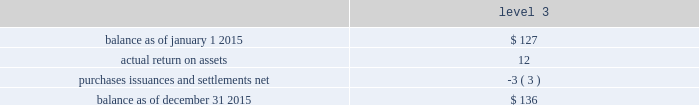The tables present a reconciliation of the beginning and ending balances of the fair value measurements using significant unobservable inputs ( level 3 ) for 2015 and 2014 , respectively: .
Purchases , issuances and settlements , net .
76 balance as of december 31 , 2014 .
$ 127 the company 2019s other postretirement benefit plans are partially funded and the assets are held under various trusts .
The investments and risk mitigation strategies for the plans are tailored specifically for each trust .
In setting new strategic asset mixes , consideration is given to the likelihood that the selected asset allocation will effectively fund the projected plan liabilities and the risk tolerance of the company .
The company periodically updates the long-term , strategic asset allocations and uses various analytics to determine the optimal asset allocation .
Considerations include plan liability characteristics , liquidity characteristics , funding requirements , expected rates of return and the distribution of returns .
In june 2012 , the company implemented a de-risking strategy for the medical bargaining trust within the plan to minimize volatility .
As part of the de-risking strategy , the company revised the asset allocations to increase the matching characteristics of assets relative to liabilities .
The initial de-risking asset allocation for the plan was 60% ( 60 % ) return-generating assets and 40% ( 40 % ) liability-driven assets .
The investment strategies and policies for the plan reflect a balance of liability driven and return-generating considerations .
The objective of minimizing the volatility of assets relative to liabilities is addressed primarily through asset 2014liability matching , asset diversification and hedging .
The fixed income target asset allocation matches the bond-like and long-dated nature of the postretirement liabilities .
Assets are broadly diversified within asset classes to achieve risk-adjusted returns that in total lower asset volatility relative to the liabilities .
The company assesses the investment strategy regularly to ensure actual allocations are in line with target allocations as appropriate .
Strategies to address the goal of ensuring sufficient assets to pay benefits include target allocations to a broad array of asset classes and , within asset classes strategies are employed to provide adequate returns , diversification and liquidity .
The assets of the company 2019s other trusts , within the other postretirement benefit plans , have been primarily invested in equities and fixed income funds .
The assets under the various other postretirement benefit trusts are invested differently based on the assets and liabilities of each trust .
The obligations of the other postretirement benefit plans are dominated by obligations for the medical bargaining trust .
Thirty-nine percent and four percent of the total postretirement plan benefit obligations are related to the medical non-bargaining and life insurance trusts , respectively .
Because expected benefit payments related to the benefit obligations are so far into the future , and the size of the medical non-bargaining and life insurance trusts 2019 obligations are large compared to each trusts 2019 assets , the investment strategy is to allocate a significant portion of the assets 2019 investment to equities , which the company believes will provide the highest long-term return and improve the funding ratio .
The company engages third party investment managers for all invested assets .
Managers are not permitted to invest outside of the asset class ( e.g .
Fixed income , equity , alternatives ) or strategy for which they have been appointed .
Investment management agreements and recurring performance and attribution analysis are used as tools to ensure investment managers invest solely within the investment strategy they have been provided .
Futures and options may be used to adjust portfolio duration to align with a plan 2019s targeted investment policy. .
What is the total balance of purchases , issuances and settlements at the end of 2015? 
Computations: (76 + -3)
Answer: 73.0. 